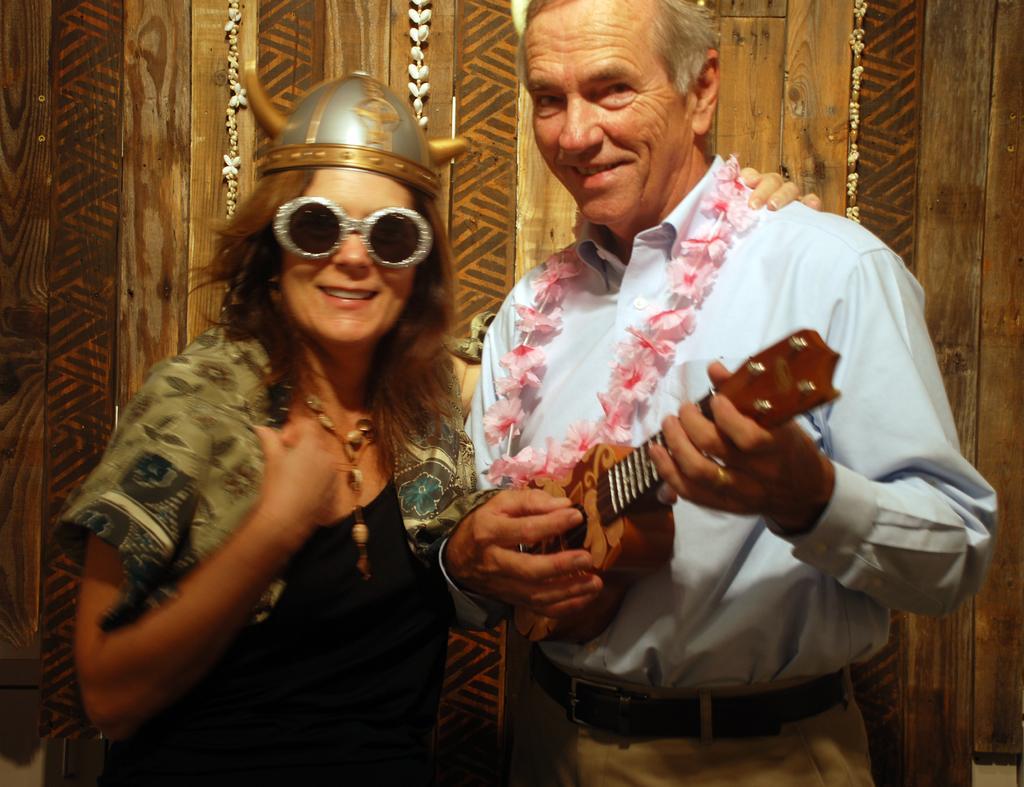How would you summarize this image in a sentence or two? In this image I see a woman and a man and both of them are laughing, I also see that this man is holding a guitar. 